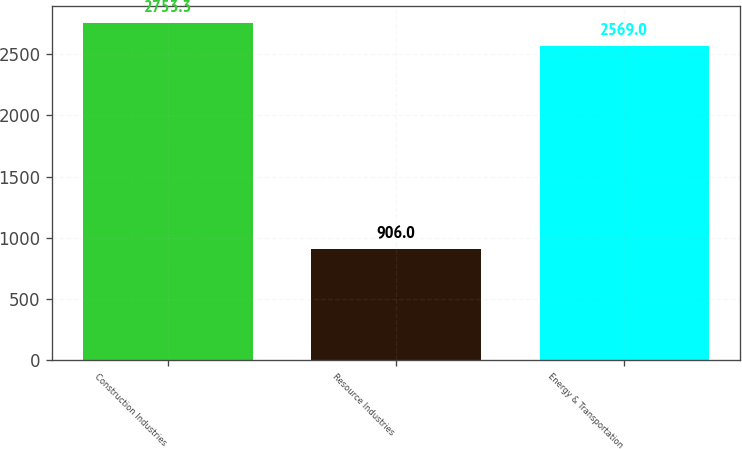Convert chart. <chart><loc_0><loc_0><loc_500><loc_500><bar_chart><fcel>Construction Industries<fcel>Resource Industries<fcel>Energy & Transportation<nl><fcel>2753.3<fcel>906<fcel>2569<nl></chart> 